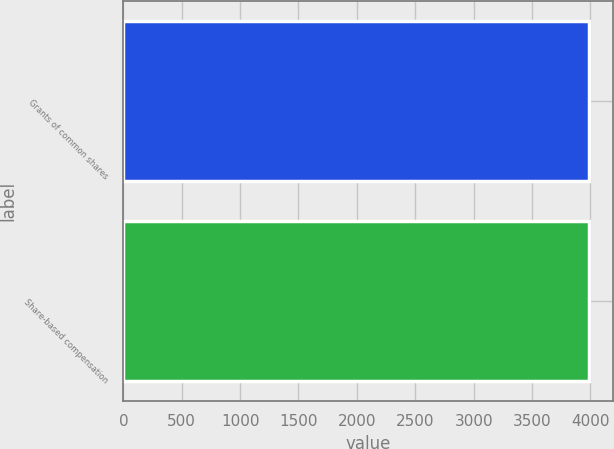Convert chart. <chart><loc_0><loc_0><loc_500><loc_500><bar_chart><fcel>Grants of common shares<fcel>Share-based compensation<nl><fcel>3992<fcel>3992.1<nl></chart> 